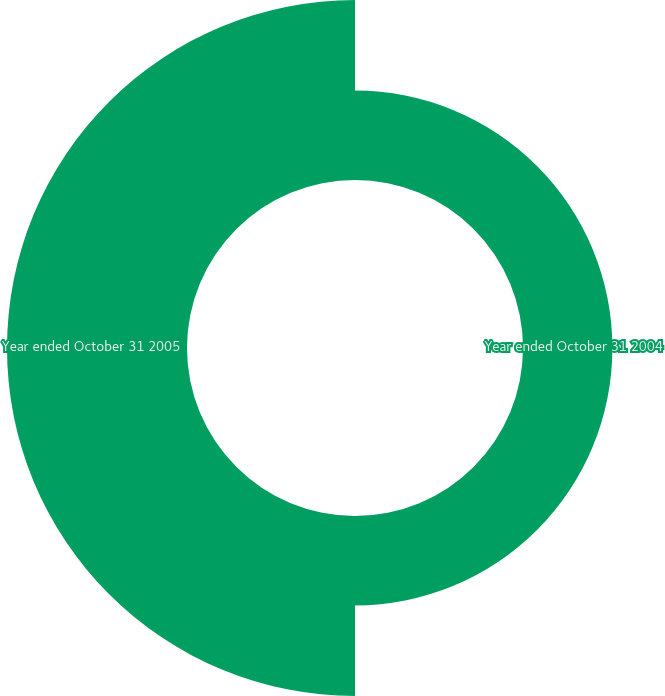Convert chart. <chart><loc_0><loc_0><loc_500><loc_500><pie_chart><fcel>Year ended October 31 2004<fcel>Year ended October 31 2005<nl><fcel>33.18%<fcel>66.82%<nl></chart> 